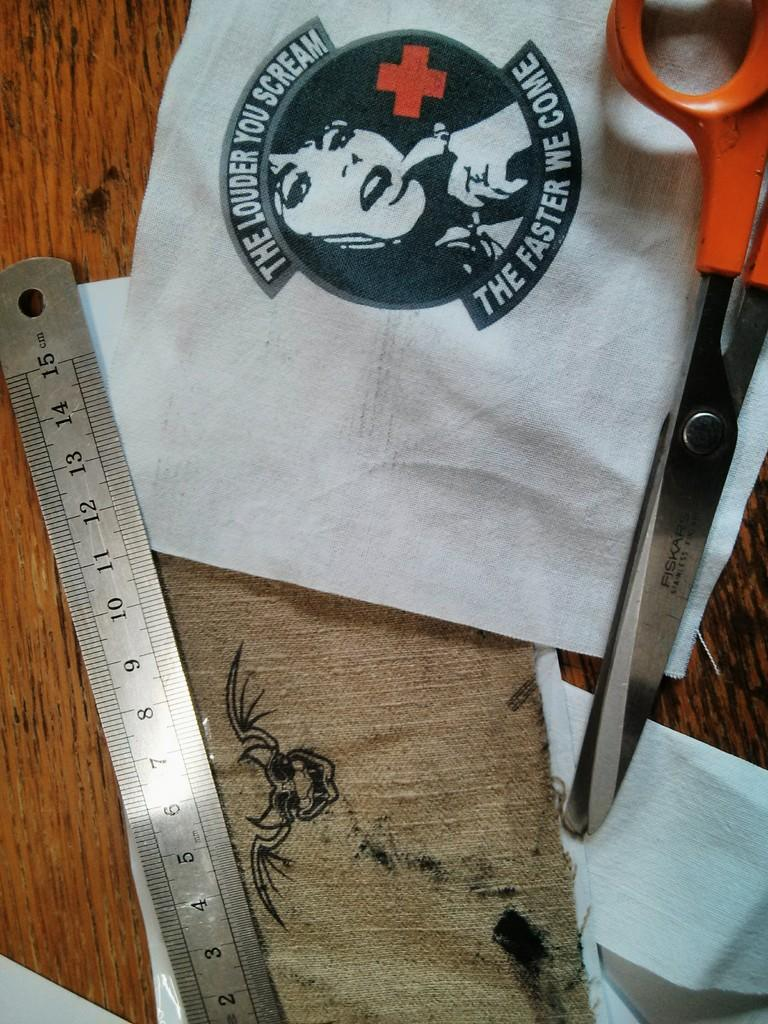<image>
Describe the image concisely. A saucy joke logo is bordered by a slogan saying The Louder You Scream The Faster We Come. 